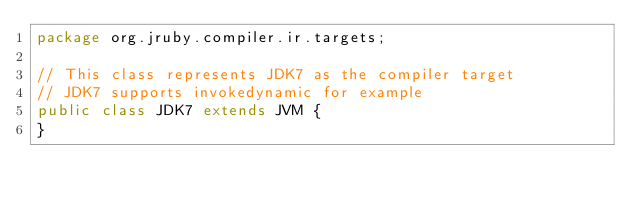<code> <loc_0><loc_0><loc_500><loc_500><_Java_>package org.jruby.compiler.ir.targets;

// This class represents JDK7 as the compiler target
// JDK7 supports invokedynamic for example
public class JDK7 extends JVM {
}
</code> 